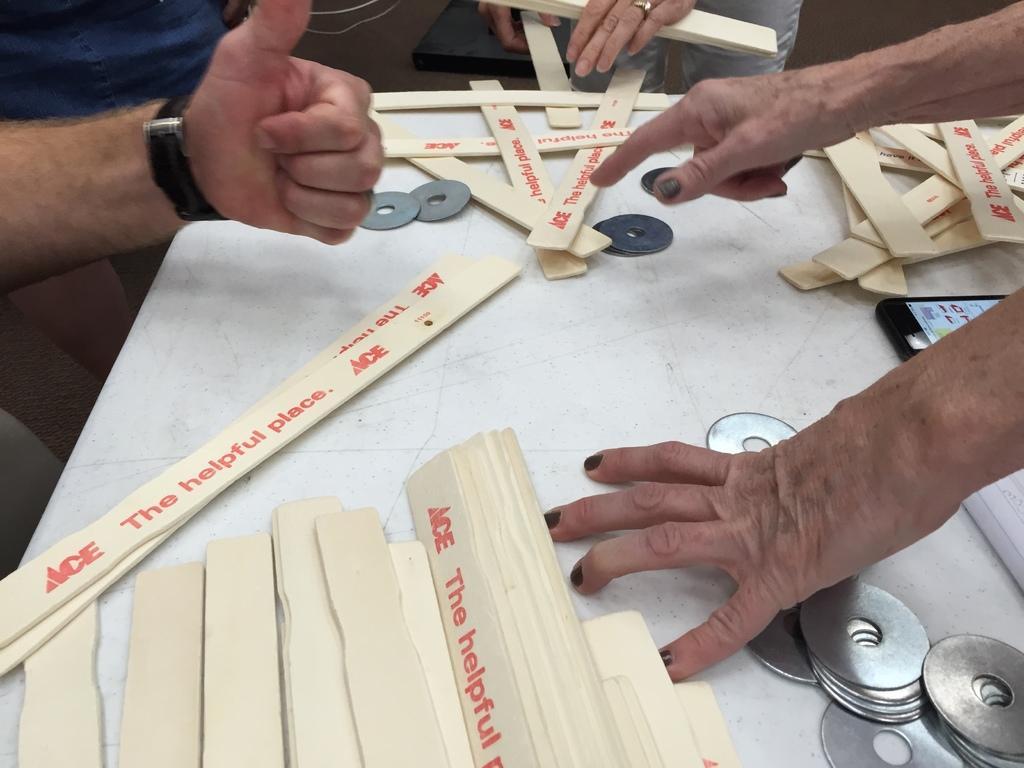How would you summarize this image in a sentence or two? In this image there is a table. There are wooden pieces, metal pieces and a mobile phone on the table. Above the table there are hands of persons. To the left there is a watch to a hand. 